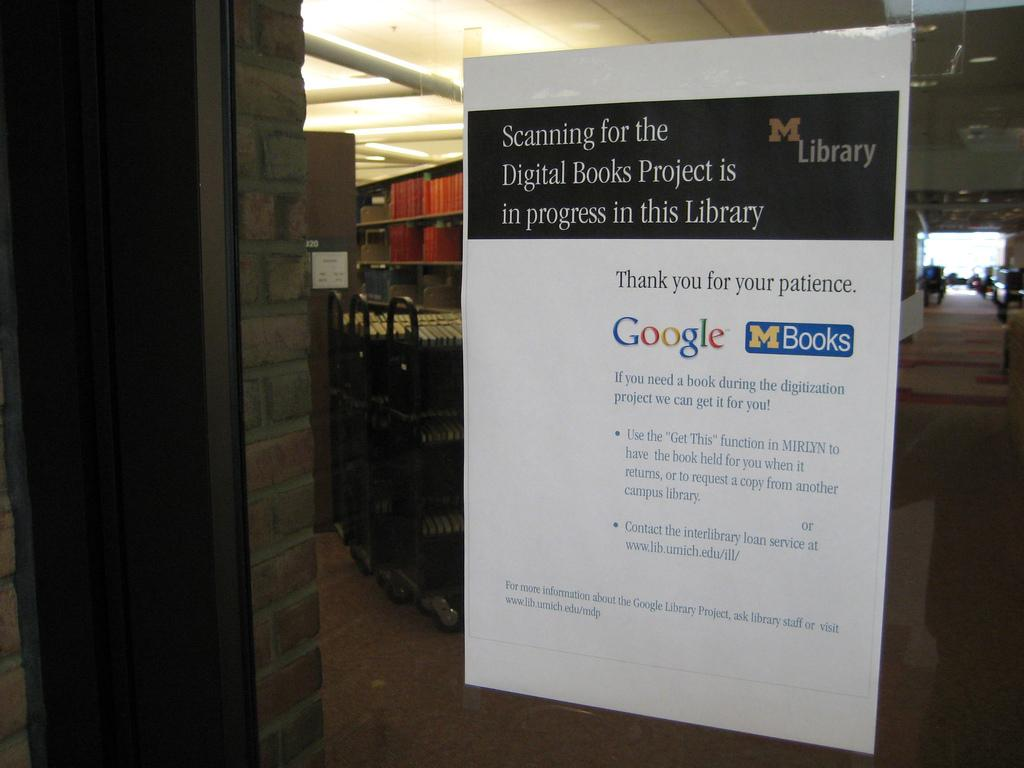<image>
Relay a brief, clear account of the picture shown. The library is hosting a project to use digital books. 